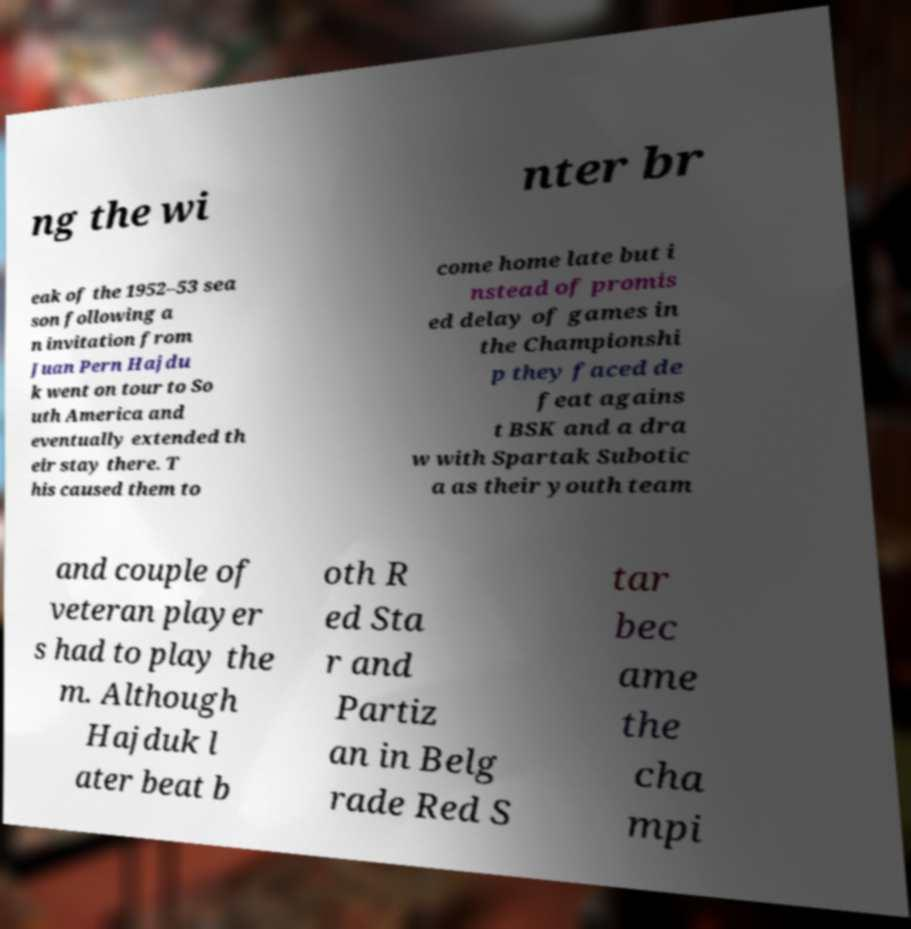Can you accurately transcribe the text from the provided image for me? ng the wi nter br eak of the 1952–53 sea son following a n invitation from Juan Pern Hajdu k went on tour to So uth America and eventually extended th eir stay there. T his caused them to come home late but i nstead of promis ed delay of games in the Championshi p they faced de feat agains t BSK and a dra w with Spartak Subotic a as their youth team and couple of veteran player s had to play the m. Although Hajduk l ater beat b oth R ed Sta r and Partiz an in Belg rade Red S tar bec ame the cha mpi 